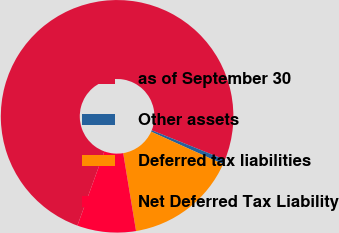Convert chart. <chart><loc_0><loc_0><loc_500><loc_500><pie_chart><fcel>as of September 30<fcel>Other assets<fcel>Deferred tax liabilities<fcel>Net Deferred Tax Liability<nl><fcel>75.55%<fcel>0.66%<fcel>15.64%<fcel>8.15%<nl></chart> 